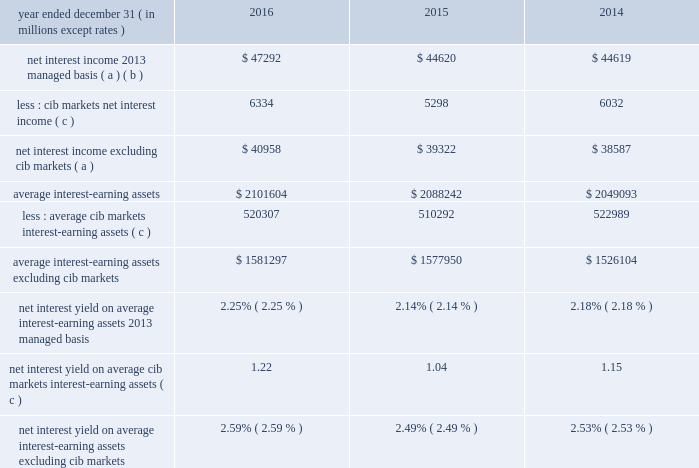Jpmorgan chase & co./2016 annual report 49 net interest income excluding cib 2019s markets businesses in addition to reviewing net interest income on a managed basis , management also reviews net interest income excluding net interest income arising from cib 2019s markets businesses to assess the performance of the firm 2019s lending , investing ( including asset-liability management ) and deposit-raising activities .
Cib 2019s markets businesses represent both fixed income markets and equity markets .
The data presented below are non-gaap financial measures due to the exclusion of net interest income from cib 2019s markets businesses ( 201ccib markets 201d ) .
Management believes this exclusion provides investors and analysts with another measure by which to analyze the non- markets-related business trends of the firm and provides a comparable measure to other financial institutions that are primarily focused on lending , investing and deposit-raising activities .
Year ended december 31 , ( in millions , except rates ) 2016 2015 2014 net interest income 2013 managed basis ( a ) ( b ) $ 47292 $ 44620 $ 44619 less : cib markets net interest income ( c ) 6334 5298 6032 net interest income excluding cib markets ( a ) $ 40958 $ 39322 $ 38587 average interest-earning assets $ 2101604 $ 2088242 $ 2049093 less : average cib markets interest-earning assets ( c ) 520307 510292 522989 average interest-earning assets excluding cib markets $ 1581297 $ 1577950 $ 1526104 net interest yield on average interest-earning assets 2013 managed basis 2.25% ( 2.25 % ) 2.14% ( 2.14 % ) 2.18% ( 2.18 % ) net interest yield on average cib markets interest- earning assets ( c ) 1.22 1.04 1.15 net interest yield on average interest-earning assets excluding cib markets 2.59% ( 2.59 % ) 2.49% ( 2.49 % ) 2.53% ( 2.53 % ) ( a ) interest includes the effect of related hedges .
Taxable-equivalent amounts are used where applicable .
( b ) for a reconciliation of net interest income on a reported and managed basis , see reconciliation from the firm 2019s reported u.s .
Gaap results to managed basis on page 48 .
( c ) prior period amounts were revised to align with cib 2019s markets businesses .
For further information on cib 2019s markets businesses , see page 61 .
Calculation of certain u.s .
Gaap and non-gaap financial measures certain u.s .
Gaap and non-gaap financial measures are calculated as follows : book value per share ( 201cbvps 201d ) common stockholders 2019 equity at period-end / common shares at period-end overhead ratio total noninterest expense / total net revenue return on assets ( 201croa 201d ) reported net income / total average assets return on common equity ( 201croe 201d ) net income* / average common stockholders 2019 equity return on tangible common equity ( 201crotce 201d ) net income* / average tangible common equity tangible book value per share ( 201ctbvps 201d ) tangible common equity at period-end / common shares at period-end * represents net income applicable to common equity .
Jpmorgan chase & co./2016 annual report 49 net interest income excluding cib 2019s markets businesses in addition to reviewing net interest income on a managed basis , management also reviews net interest income excluding net interest income arising from cib 2019s markets businesses to assess the performance of the firm 2019s lending , investing ( including asset-liability management ) and deposit-raising activities .
Cib 2019s markets businesses represent both fixed income markets and equity markets .
The data presented below are non-gaap financial measures due to the exclusion of net interest income from cib 2019s markets businesses ( 201ccib markets 201d ) .
Management believes this exclusion provides investors and analysts with another measure by which to analyze the non- markets-related business trends of the firm and provides a comparable measure to other financial institutions that are primarily focused on lending , investing and deposit-raising activities .
Year ended december 31 , ( in millions , except rates ) 2016 2015 2014 net interest income 2013 managed basis ( a ) ( b ) $ 47292 $ 44620 $ 44619 less : cib markets net interest income ( c ) 6334 5298 6032 net interest income excluding cib markets ( a ) $ 40958 $ 39322 $ 38587 average interest-earning assets $ 2101604 $ 2088242 $ 2049093 less : average cib markets interest-earning assets ( c ) 520307 510292 522989 average interest-earning assets excluding cib markets $ 1581297 $ 1577950 $ 1526104 net interest yield on average interest-earning assets 2013 managed basis 2.25% ( 2.25 % ) 2.14% ( 2.14 % ) 2.18% ( 2.18 % ) net interest yield on average cib markets interest- earning assets ( c ) 1.22 1.04 1.15 net interest yield on average interest-earning assets excluding cib markets 2.59% ( 2.59 % ) 2.49% ( 2.49 % ) 2.53% ( 2.53 % ) ( a ) interest includes the effect of related hedges .
Taxable-equivalent amounts are used where applicable .
( b ) for a reconciliation of net interest income on a reported and managed basis , see reconciliation from the firm 2019s reported u.s .
Gaap results to managed basis on page 48 .
( c ) prior period amounts were revised to align with cib 2019s markets businesses .
For further information on cib 2019s markets businesses , see page 61 .
Calculation of certain u.s .
Gaap and non-gaap financial measures certain u.s .
Gaap and non-gaap financial measures are calculated as follows : book value per share ( 201cbvps 201d ) common stockholders 2019 equity at period-end / common shares at period-end overhead ratio total noninterest expense / total net revenue return on assets ( 201croa 201d ) reported net income / total average assets return on common equity ( 201croe 201d ) net income* / average common stockholders 2019 equity return on tangible common equity ( 201crotce 201d ) net income* / average tangible common equity tangible book value per share ( 201ctbvps 201d ) tangible common equity at period-end / common shares at period-end * represents net income applicable to common equity .
In 2016 what was the percent of the cib markets net interest income as part of the net interest income 2013 managed basis? 
Computations: (6334 / 47292)
Answer: 0.13393. Jpmorgan chase & co./2016 annual report 49 net interest income excluding cib 2019s markets businesses in addition to reviewing net interest income on a managed basis , management also reviews net interest income excluding net interest income arising from cib 2019s markets businesses to assess the performance of the firm 2019s lending , investing ( including asset-liability management ) and deposit-raising activities .
Cib 2019s markets businesses represent both fixed income markets and equity markets .
The data presented below are non-gaap financial measures due to the exclusion of net interest income from cib 2019s markets businesses ( 201ccib markets 201d ) .
Management believes this exclusion provides investors and analysts with another measure by which to analyze the non- markets-related business trends of the firm and provides a comparable measure to other financial institutions that are primarily focused on lending , investing and deposit-raising activities .
Year ended december 31 , ( in millions , except rates ) 2016 2015 2014 net interest income 2013 managed basis ( a ) ( b ) $ 47292 $ 44620 $ 44619 less : cib markets net interest income ( c ) 6334 5298 6032 net interest income excluding cib markets ( a ) $ 40958 $ 39322 $ 38587 average interest-earning assets $ 2101604 $ 2088242 $ 2049093 less : average cib markets interest-earning assets ( c ) 520307 510292 522989 average interest-earning assets excluding cib markets $ 1581297 $ 1577950 $ 1526104 net interest yield on average interest-earning assets 2013 managed basis 2.25% ( 2.25 % ) 2.14% ( 2.14 % ) 2.18% ( 2.18 % ) net interest yield on average cib markets interest- earning assets ( c ) 1.22 1.04 1.15 net interest yield on average interest-earning assets excluding cib markets 2.59% ( 2.59 % ) 2.49% ( 2.49 % ) 2.53% ( 2.53 % ) ( a ) interest includes the effect of related hedges .
Taxable-equivalent amounts are used where applicable .
( b ) for a reconciliation of net interest income on a reported and managed basis , see reconciliation from the firm 2019s reported u.s .
Gaap results to managed basis on page 48 .
( c ) prior period amounts were revised to align with cib 2019s markets businesses .
For further information on cib 2019s markets businesses , see page 61 .
Calculation of certain u.s .
Gaap and non-gaap financial measures certain u.s .
Gaap and non-gaap financial measures are calculated as follows : book value per share ( 201cbvps 201d ) common stockholders 2019 equity at period-end / common shares at period-end overhead ratio total noninterest expense / total net revenue return on assets ( 201croa 201d ) reported net income / total average assets return on common equity ( 201croe 201d ) net income* / average common stockholders 2019 equity return on tangible common equity ( 201crotce 201d ) net income* / average tangible common equity tangible book value per share ( 201ctbvps 201d ) tangible common equity at period-end / common shares at period-end * represents net income applicable to common equity .
Jpmorgan chase & co./2016 annual report 49 net interest income excluding cib 2019s markets businesses in addition to reviewing net interest income on a managed basis , management also reviews net interest income excluding net interest income arising from cib 2019s markets businesses to assess the performance of the firm 2019s lending , investing ( including asset-liability management ) and deposit-raising activities .
Cib 2019s markets businesses represent both fixed income markets and equity markets .
The data presented below are non-gaap financial measures due to the exclusion of net interest income from cib 2019s markets businesses ( 201ccib markets 201d ) .
Management believes this exclusion provides investors and analysts with another measure by which to analyze the non- markets-related business trends of the firm and provides a comparable measure to other financial institutions that are primarily focused on lending , investing and deposit-raising activities .
Year ended december 31 , ( in millions , except rates ) 2016 2015 2014 net interest income 2013 managed basis ( a ) ( b ) $ 47292 $ 44620 $ 44619 less : cib markets net interest income ( c ) 6334 5298 6032 net interest income excluding cib markets ( a ) $ 40958 $ 39322 $ 38587 average interest-earning assets $ 2101604 $ 2088242 $ 2049093 less : average cib markets interest-earning assets ( c ) 520307 510292 522989 average interest-earning assets excluding cib markets $ 1581297 $ 1577950 $ 1526104 net interest yield on average interest-earning assets 2013 managed basis 2.25% ( 2.25 % ) 2.14% ( 2.14 % ) 2.18% ( 2.18 % ) net interest yield on average cib markets interest- earning assets ( c ) 1.22 1.04 1.15 net interest yield on average interest-earning assets excluding cib markets 2.59% ( 2.59 % ) 2.49% ( 2.49 % ) 2.53% ( 2.53 % ) ( a ) interest includes the effect of related hedges .
Taxable-equivalent amounts are used where applicable .
( b ) for a reconciliation of net interest income on a reported and managed basis , see reconciliation from the firm 2019s reported u.s .
Gaap results to managed basis on page 48 .
( c ) prior period amounts were revised to align with cib 2019s markets businesses .
For further information on cib 2019s markets businesses , see page 61 .
Calculation of certain u.s .
Gaap and non-gaap financial measures certain u.s .
Gaap and non-gaap financial measures are calculated as follows : book value per share ( 201cbvps 201d ) common stockholders 2019 equity at period-end / common shares at period-end overhead ratio total noninterest expense / total net revenue return on assets ( 201croa 201d ) reported net income / total average assets return on common equity ( 201croe 201d ) net income* / average common stockholders 2019 equity return on tangible common equity ( 201crotce 201d ) net income* / average tangible common equity tangible book value per share ( 201ctbvps 201d ) tangible common equity at period-end / common shares at period-end * represents net income applicable to common equity .
What would a 225bp yield be on the 2016 average interest-earning assets , in millions? 
Computations: (2101604 * 2.25%)
Answer: 47286.09. 